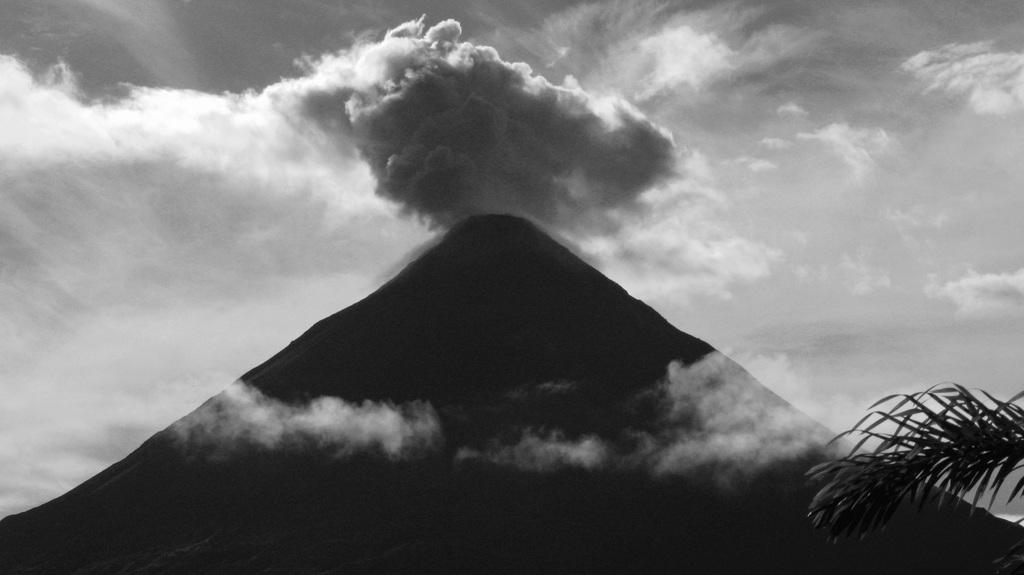What type of natural formation is visible in the image? There is a mountain in the image. What is the condition of the sky in the image? The sky is covered with clouds. What can be seen on the right side of the image? There is a branch of a tree on the right side of the image. What type of punishment is being handed out by the grandfather in the image? There is no grandfather or punishment present in the image. 